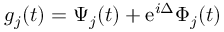<formula> <loc_0><loc_0><loc_500><loc_500>g _ { j } ( t ) = \Psi _ { j } ( t ) + e ^ { i \Delta } \Phi _ { j } ( t )</formula> 